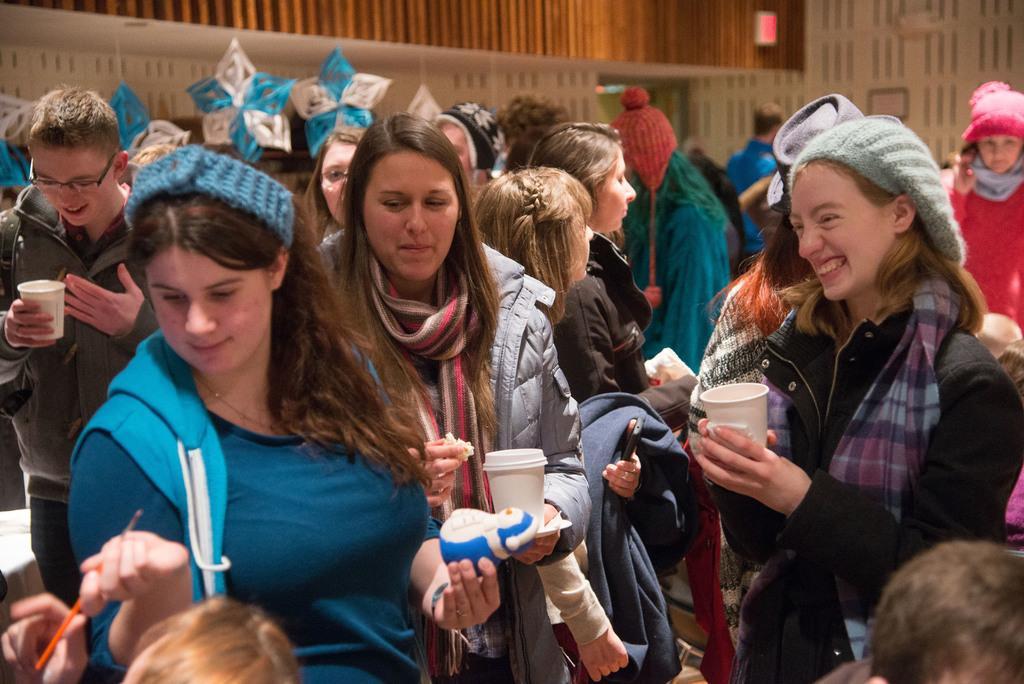In one or two sentences, can you explain what this image depicts? In this picture I can see group of people standing and holding some objects, there are few decorative items, and in the background there is a wall. 